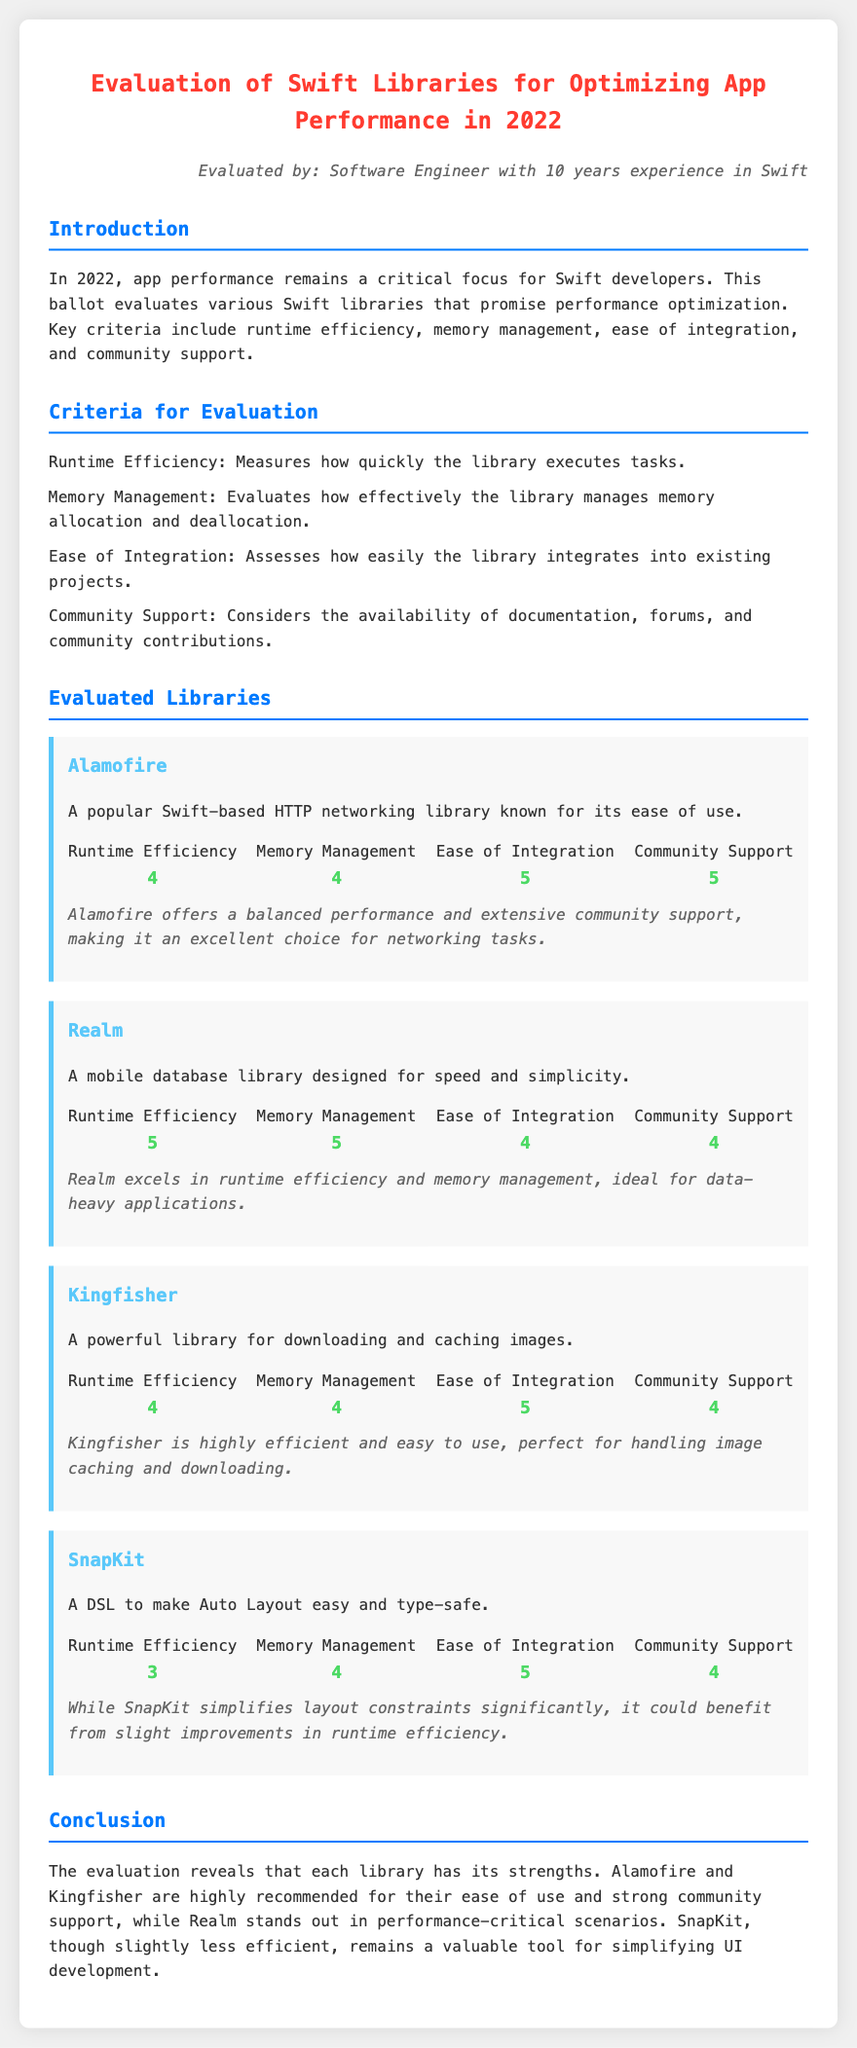what is the title of the document? The title of the document is presented at the top of the rendered content.
Answer: Evaluation of Swift Libraries for Optimizing App Performance in 2022 who is the evaluated by persona? The persona indicated in the document states who conducted the evaluation.
Answer: Software Engineer with 10 years experience in Swift how many criteria are used for evaluation? The document lists specific criteria for the evaluation of libraries.
Answer: 4 what is the runtime efficiency score of Alamofire? The score for runtime efficiency is provided in the evaluation section of the specific library.
Answer: 4 which library scored the highest in memory management? The document specifies the scores for memory management for each library individually.
Answer: Realm what is the main focus for Swift developers in 2022? The introduction section summarizes the primary concern for developers during that year.
Answer: App performance which library is recommended for performance-critical scenarios? The conclusion summarizes recommendations based on the evaluations provided.
Answer: Realm what aspect does SnapKit simplify? The description of SnapKit highlights its primary functionality.
Answer: Layout constraints 